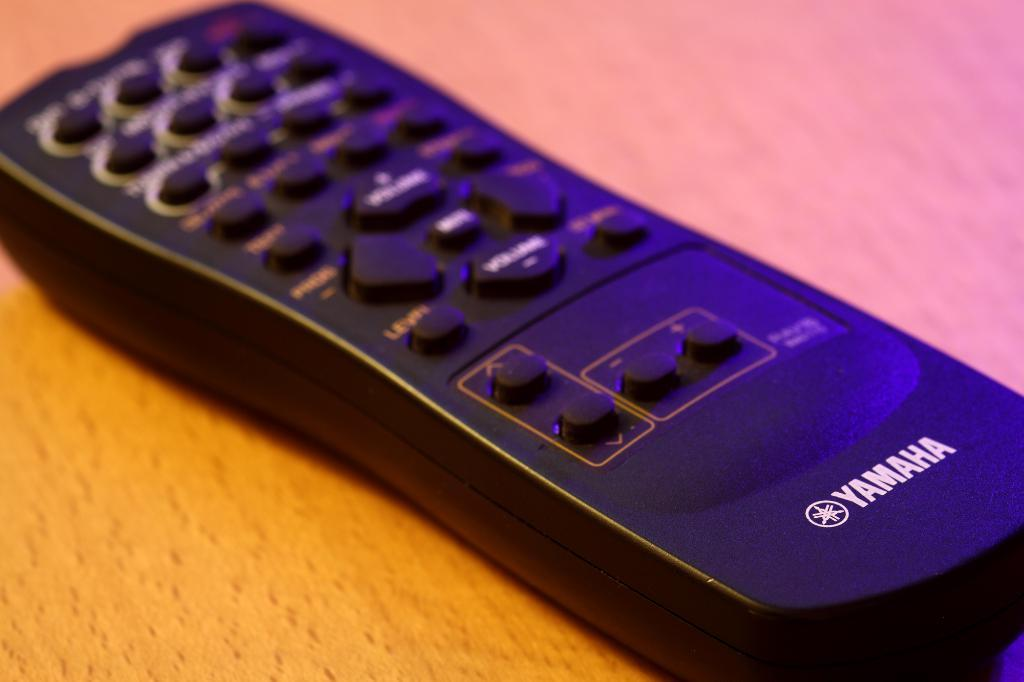<image>
Write a terse but informative summary of the picture. a black television remote control with the logo for yamaha on the bottom. 